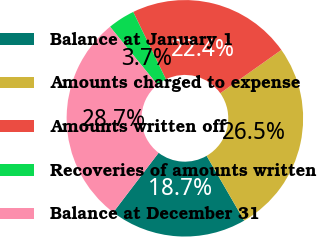Convert chart. <chart><loc_0><loc_0><loc_500><loc_500><pie_chart><fcel>Balance at January 1<fcel>Amounts charged to expense<fcel>Amounts written off<fcel>Recoveries of amounts written<fcel>Balance at December 31<nl><fcel>18.72%<fcel>26.45%<fcel>22.39%<fcel>3.71%<fcel>28.73%<nl></chart> 